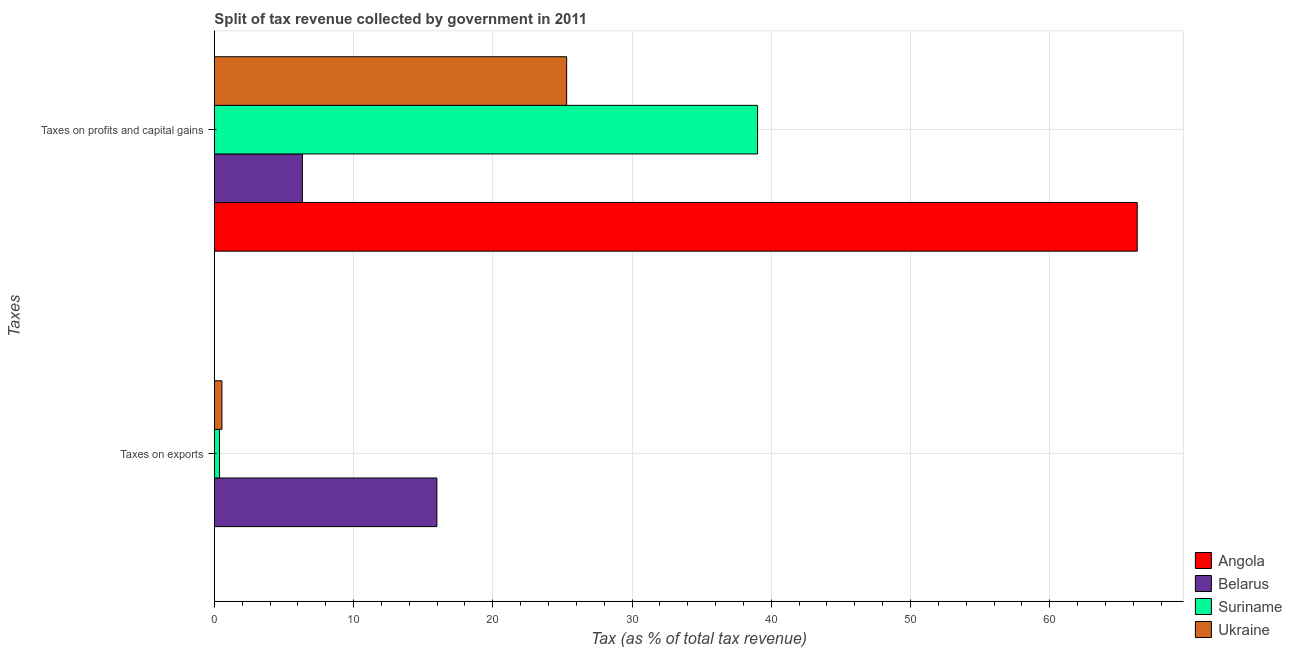How many groups of bars are there?
Offer a very short reply. 2. Are the number of bars per tick equal to the number of legend labels?
Make the answer very short. Yes. Are the number of bars on each tick of the Y-axis equal?
Ensure brevity in your answer.  Yes. What is the label of the 2nd group of bars from the top?
Your response must be concise. Taxes on exports. What is the percentage of revenue obtained from taxes on exports in Angola?
Provide a short and direct response. 0. Across all countries, what is the maximum percentage of revenue obtained from taxes on exports?
Provide a short and direct response. 15.98. Across all countries, what is the minimum percentage of revenue obtained from taxes on profits and capital gains?
Your response must be concise. 6.32. In which country was the percentage of revenue obtained from taxes on exports maximum?
Your answer should be very brief. Belarus. In which country was the percentage of revenue obtained from taxes on profits and capital gains minimum?
Offer a terse response. Belarus. What is the total percentage of revenue obtained from taxes on exports in the graph?
Keep it short and to the point. 16.9. What is the difference between the percentage of revenue obtained from taxes on exports in Ukraine and that in Belarus?
Your answer should be very brief. -15.44. What is the difference between the percentage of revenue obtained from taxes on profits and capital gains in Angola and the percentage of revenue obtained from taxes on exports in Ukraine?
Your answer should be very brief. 65.74. What is the average percentage of revenue obtained from taxes on exports per country?
Give a very brief answer. 4.23. What is the difference between the percentage of revenue obtained from taxes on profits and capital gains and percentage of revenue obtained from taxes on exports in Belarus?
Provide a succinct answer. -9.66. What is the ratio of the percentage of revenue obtained from taxes on profits and capital gains in Ukraine to that in Belarus?
Make the answer very short. 4. What does the 1st bar from the top in Taxes on exports represents?
Your response must be concise. Ukraine. What does the 2nd bar from the bottom in Taxes on profits and capital gains represents?
Keep it short and to the point. Belarus. How many bars are there?
Ensure brevity in your answer.  8. What is the difference between two consecutive major ticks on the X-axis?
Offer a terse response. 10. Does the graph contain any zero values?
Offer a very short reply. No. Does the graph contain grids?
Provide a succinct answer. Yes. How many legend labels are there?
Make the answer very short. 4. How are the legend labels stacked?
Make the answer very short. Vertical. What is the title of the graph?
Offer a very short reply. Split of tax revenue collected by government in 2011. What is the label or title of the X-axis?
Offer a very short reply. Tax (as % of total tax revenue). What is the label or title of the Y-axis?
Your response must be concise. Taxes. What is the Tax (as % of total tax revenue) in Angola in Taxes on exports?
Make the answer very short. 0. What is the Tax (as % of total tax revenue) of Belarus in Taxes on exports?
Give a very brief answer. 15.98. What is the Tax (as % of total tax revenue) of Suriname in Taxes on exports?
Keep it short and to the point. 0.37. What is the Tax (as % of total tax revenue) in Ukraine in Taxes on exports?
Offer a terse response. 0.54. What is the Tax (as % of total tax revenue) of Angola in Taxes on profits and capital gains?
Your answer should be very brief. 66.28. What is the Tax (as % of total tax revenue) of Belarus in Taxes on profits and capital gains?
Give a very brief answer. 6.32. What is the Tax (as % of total tax revenue) in Suriname in Taxes on profits and capital gains?
Offer a very short reply. 39.01. What is the Tax (as % of total tax revenue) in Ukraine in Taxes on profits and capital gains?
Provide a succinct answer. 25.3. Across all Taxes, what is the maximum Tax (as % of total tax revenue) in Angola?
Provide a short and direct response. 66.28. Across all Taxes, what is the maximum Tax (as % of total tax revenue) in Belarus?
Provide a succinct answer. 15.98. Across all Taxes, what is the maximum Tax (as % of total tax revenue) of Suriname?
Make the answer very short. 39.01. Across all Taxes, what is the maximum Tax (as % of total tax revenue) of Ukraine?
Provide a short and direct response. 25.3. Across all Taxes, what is the minimum Tax (as % of total tax revenue) in Angola?
Keep it short and to the point. 0. Across all Taxes, what is the minimum Tax (as % of total tax revenue) in Belarus?
Give a very brief answer. 6.32. Across all Taxes, what is the minimum Tax (as % of total tax revenue) of Suriname?
Your answer should be very brief. 0.37. Across all Taxes, what is the minimum Tax (as % of total tax revenue) of Ukraine?
Make the answer very short. 0.54. What is the total Tax (as % of total tax revenue) in Angola in the graph?
Provide a succinct answer. 66.28. What is the total Tax (as % of total tax revenue) in Belarus in the graph?
Your answer should be very brief. 22.31. What is the total Tax (as % of total tax revenue) of Suriname in the graph?
Your answer should be compact. 39.39. What is the total Tax (as % of total tax revenue) of Ukraine in the graph?
Ensure brevity in your answer.  25.85. What is the difference between the Tax (as % of total tax revenue) in Angola in Taxes on exports and that in Taxes on profits and capital gains?
Give a very brief answer. -66.28. What is the difference between the Tax (as % of total tax revenue) of Belarus in Taxes on exports and that in Taxes on profits and capital gains?
Your answer should be compact. 9.66. What is the difference between the Tax (as % of total tax revenue) in Suriname in Taxes on exports and that in Taxes on profits and capital gains?
Offer a very short reply. -38.64. What is the difference between the Tax (as % of total tax revenue) in Ukraine in Taxes on exports and that in Taxes on profits and capital gains?
Provide a succinct answer. -24.76. What is the difference between the Tax (as % of total tax revenue) of Angola in Taxes on exports and the Tax (as % of total tax revenue) of Belarus in Taxes on profits and capital gains?
Your response must be concise. -6.32. What is the difference between the Tax (as % of total tax revenue) in Angola in Taxes on exports and the Tax (as % of total tax revenue) in Suriname in Taxes on profits and capital gains?
Ensure brevity in your answer.  -39.01. What is the difference between the Tax (as % of total tax revenue) of Angola in Taxes on exports and the Tax (as % of total tax revenue) of Ukraine in Taxes on profits and capital gains?
Provide a short and direct response. -25.3. What is the difference between the Tax (as % of total tax revenue) of Belarus in Taxes on exports and the Tax (as % of total tax revenue) of Suriname in Taxes on profits and capital gains?
Keep it short and to the point. -23.03. What is the difference between the Tax (as % of total tax revenue) in Belarus in Taxes on exports and the Tax (as % of total tax revenue) in Ukraine in Taxes on profits and capital gains?
Give a very brief answer. -9.32. What is the difference between the Tax (as % of total tax revenue) in Suriname in Taxes on exports and the Tax (as % of total tax revenue) in Ukraine in Taxes on profits and capital gains?
Ensure brevity in your answer.  -24.93. What is the average Tax (as % of total tax revenue) of Angola per Taxes?
Make the answer very short. 33.14. What is the average Tax (as % of total tax revenue) of Belarus per Taxes?
Provide a succinct answer. 11.15. What is the average Tax (as % of total tax revenue) of Suriname per Taxes?
Your answer should be compact. 19.69. What is the average Tax (as % of total tax revenue) in Ukraine per Taxes?
Ensure brevity in your answer.  12.92. What is the difference between the Tax (as % of total tax revenue) of Angola and Tax (as % of total tax revenue) of Belarus in Taxes on exports?
Keep it short and to the point. -15.98. What is the difference between the Tax (as % of total tax revenue) of Angola and Tax (as % of total tax revenue) of Suriname in Taxes on exports?
Provide a succinct answer. -0.37. What is the difference between the Tax (as % of total tax revenue) of Angola and Tax (as % of total tax revenue) of Ukraine in Taxes on exports?
Make the answer very short. -0.54. What is the difference between the Tax (as % of total tax revenue) of Belarus and Tax (as % of total tax revenue) of Suriname in Taxes on exports?
Give a very brief answer. 15.61. What is the difference between the Tax (as % of total tax revenue) in Belarus and Tax (as % of total tax revenue) in Ukraine in Taxes on exports?
Make the answer very short. 15.44. What is the difference between the Tax (as % of total tax revenue) in Suriname and Tax (as % of total tax revenue) in Ukraine in Taxes on exports?
Provide a succinct answer. -0.17. What is the difference between the Tax (as % of total tax revenue) of Angola and Tax (as % of total tax revenue) of Belarus in Taxes on profits and capital gains?
Provide a succinct answer. 59.96. What is the difference between the Tax (as % of total tax revenue) in Angola and Tax (as % of total tax revenue) in Suriname in Taxes on profits and capital gains?
Offer a very short reply. 27.27. What is the difference between the Tax (as % of total tax revenue) in Angola and Tax (as % of total tax revenue) in Ukraine in Taxes on profits and capital gains?
Offer a terse response. 40.98. What is the difference between the Tax (as % of total tax revenue) in Belarus and Tax (as % of total tax revenue) in Suriname in Taxes on profits and capital gains?
Give a very brief answer. -32.69. What is the difference between the Tax (as % of total tax revenue) in Belarus and Tax (as % of total tax revenue) in Ukraine in Taxes on profits and capital gains?
Your response must be concise. -18.98. What is the difference between the Tax (as % of total tax revenue) of Suriname and Tax (as % of total tax revenue) of Ukraine in Taxes on profits and capital gains?
Provide a succinct answer. 13.71. What is the ratio of the Tax (as % of total tax revenue) of Angola in Taxes on exports to that in Taxes on profits and capital gains?
Offer a terse response. 0. What is the ratio of the Tax (as % of total tax revenue) in Belarus in Taxes on exports to that in Taxes on profits and capital gains?
Make the answer very short. 2.53. What is the ratio of the Tax (as % of total tax revenue) in Suriname in Taxes on exports to that in Taxes on profits and capital gains?
Your answer should be very brief. 0.01. What is the ratio of the Tax (as % of total tax revenue) in Ukraine in Taxes on exports to that in Taxes on profits and capital gains?
Make the answer very short. 0.02. What is the difference between the highest and the second highest Tax (as % of total tax revenue) of Angola?
Give a very brief answer. 66.28. What is the difference between the highest and the second highest Tax (as % of total tax revenue) in Belarus?
Offer a terse response. 9.66. What is the difference between the highest and the second highest Tax (as % of total tax revenue) of Suriname?
Offer a terse response. 38.64. What is the difference between the highest and the second highest Tax (as % of total tax revenue) in Ukraine?
Ensure brevity in your answer.  24.76. What is the difference between the highest and the lowest Tax (as % of total tax revenue) in Angola?
Provide a succinct answer. 66.28. What is the difference between the highest and the lowest Tax (as % of total tax revenue) in Belarus?
Ensure brevity in your answer.  9.66. What is the difference between the highest and the lowest Tax (as % of total tax revenue) in Suriname?
Your answer should be very brief. 38.64. What is the difference between the highest and the lowest Tax (as % of total tax revenue) in Ukraine?
Your answer should be very brief. 24.76. 